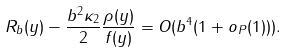Convert formula to latex. <formula><loc_0><loc_0><loc_500><loc_500>R _ { b } ( y ) - \frac { b ^ { 2 } \kappa _ { 2 } } { 2 } \frac { \rho ( y ) } { f ( y ) } = O ( b ^ { 4 } ( 1 + o _ { P } ( 1 ) ) ) .</formula> 